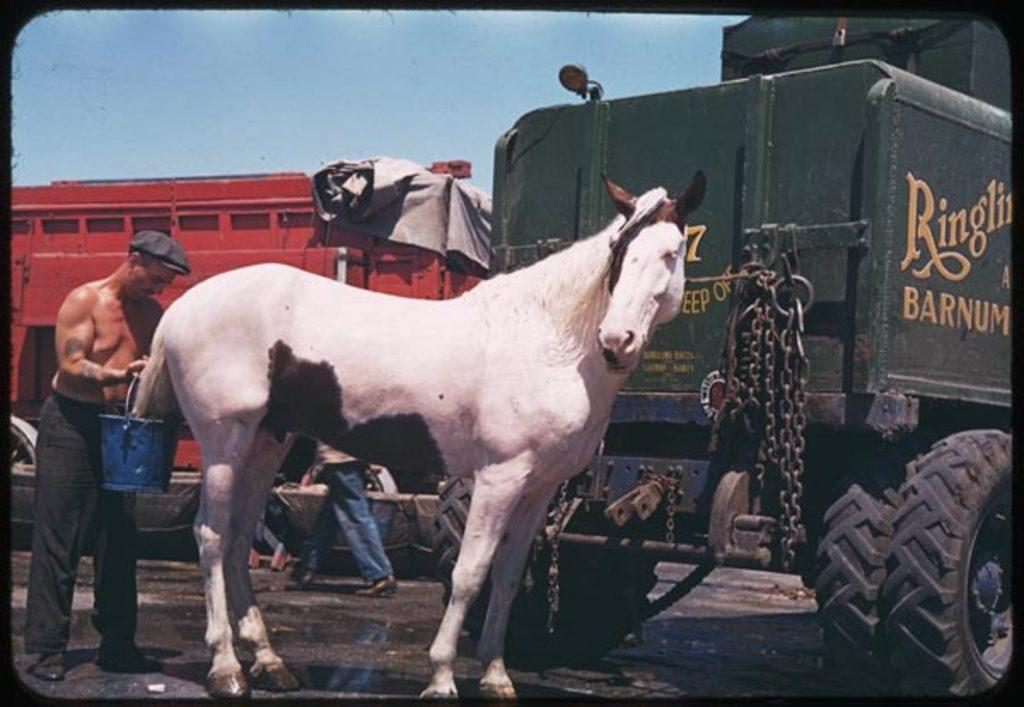What animal is present in the image? There is a horse in the image. Who is also present in the image? There is a man in the image. What is the man holding in the image? The man is holding a bucket. What type of vehicle can be seen in the image? There is a truck visible in the image. What is the owner's belief about the fact in the image? There is no information about an owner or a fact in the image, so it is not possible to answer this question. 